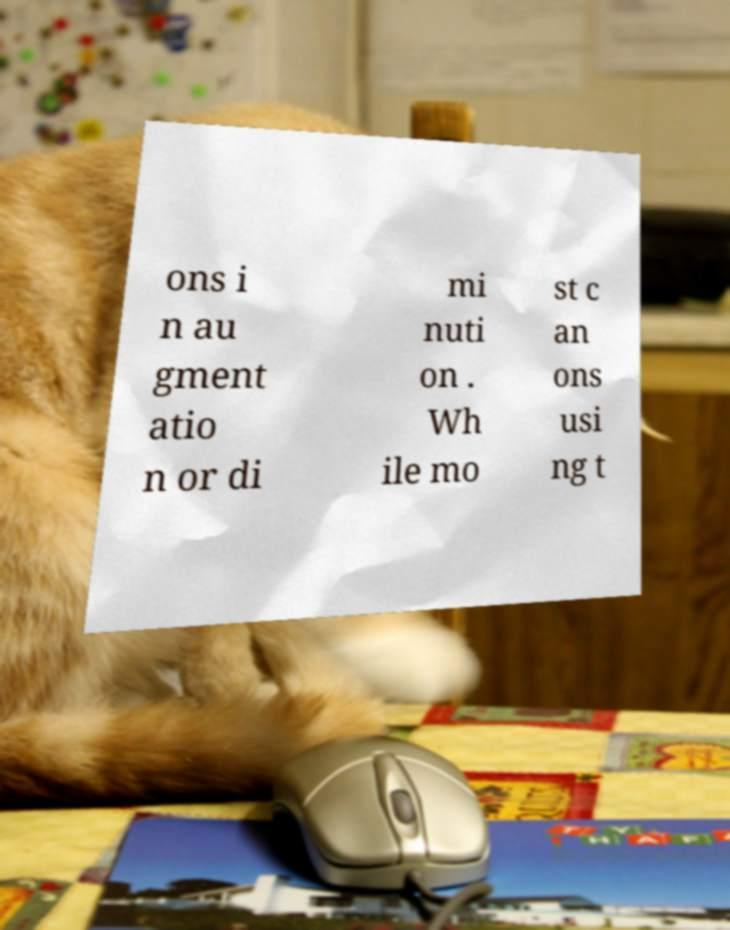I need the written content from this picture converted into text. Can you do that? ons i n au gment atio n or di mi nuti on . Wh ile mo st c an ons usi ng t 